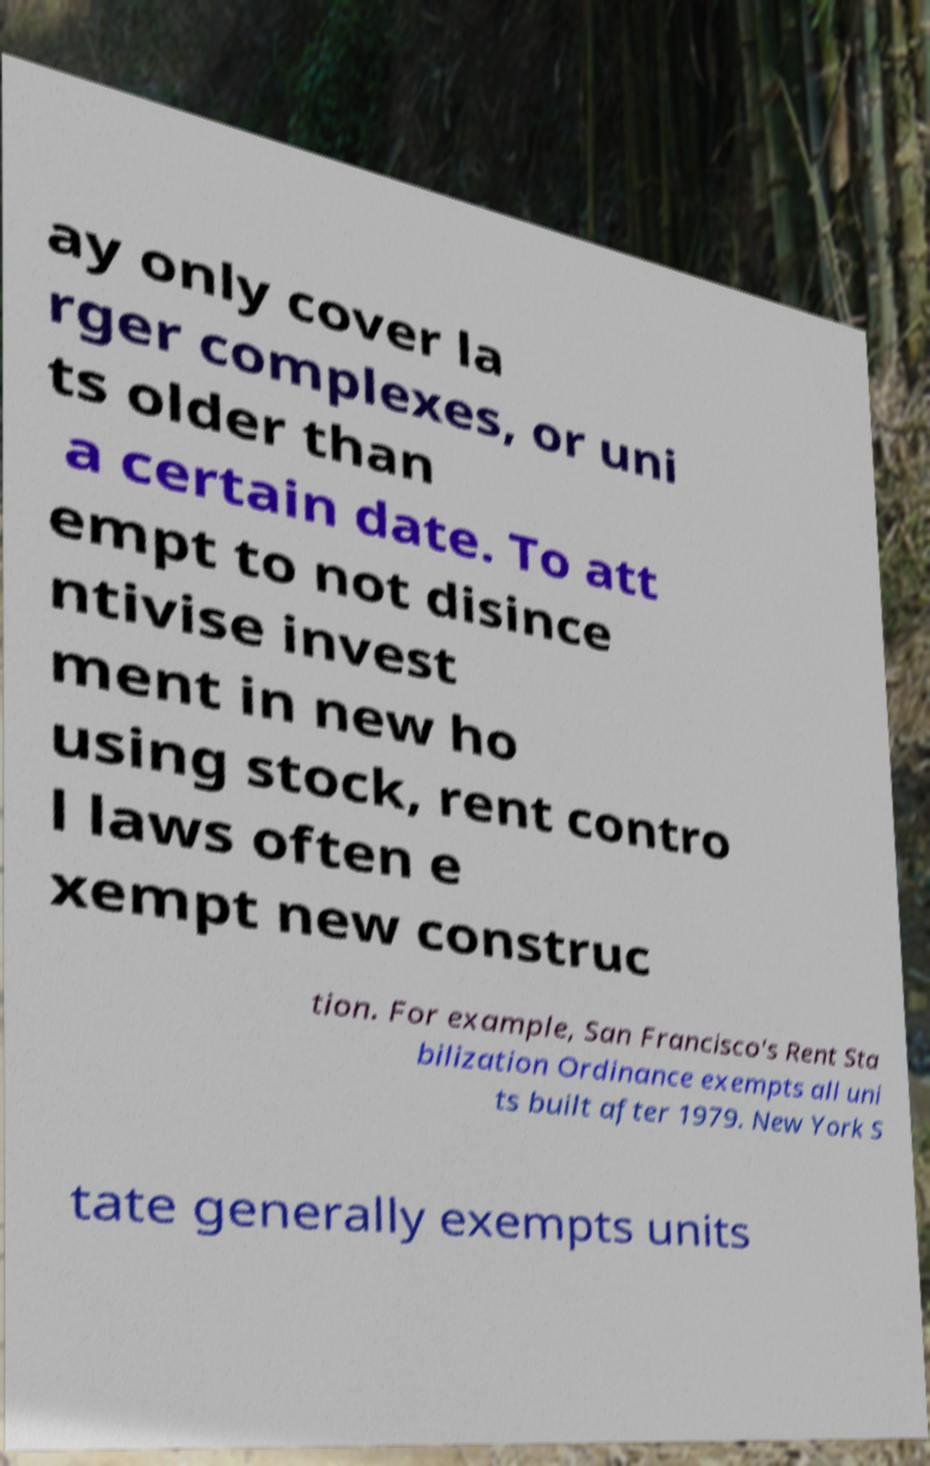Please identify and transcribe the text found in this image. ay only cover la rger complexes, or uni ts older than a certain date. To att empt to not disince ntivise invest ment in new ho using stock, rent contro l laws often e xempt new construc tion. For example, San Francisco's Rent Sta bilization Ordinance exempts all uni ts built after 1979. New York S tate generally exempts units 